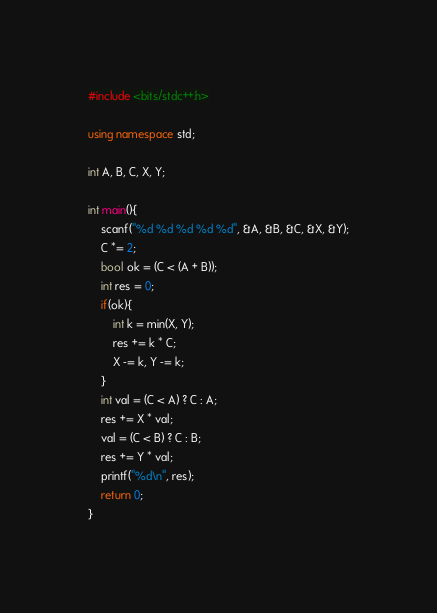<code> <loc_0><loc_0><loc_500><loc_500><_C++_>#include <bits/stdc++.h>

using namespace std;

int A, B, C, X, Y;

int main(){
	scanf("%d %d %d %d %d", &A, &B, &C, &X, &Y);
	C *= 2;
	bool ok = (C < (A + B));
	int res = 0;
	if(ok){
		int k = min(X, Y);
		res += k * C;
		X -= k, Y -= k;
	}
	int val = (C < A) ? C : A;
	res += X * val;
	val = (C < B) ? C : B;
	res += Y * val;
	printf("%d\n", res);
	return 0;
}</code> 